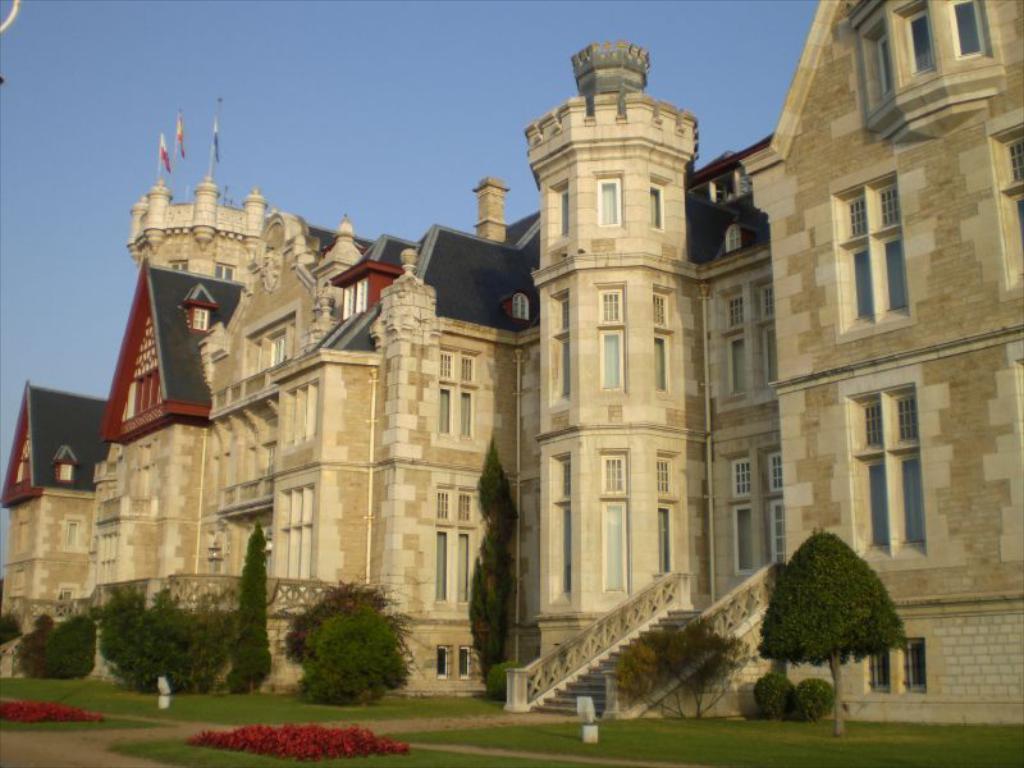Describe this image in one or two sentences. In this image I can see grass, plants, trees, staircase, buildings and windows. At the top I can see flags and the sky. This image is taken may be during a day. 